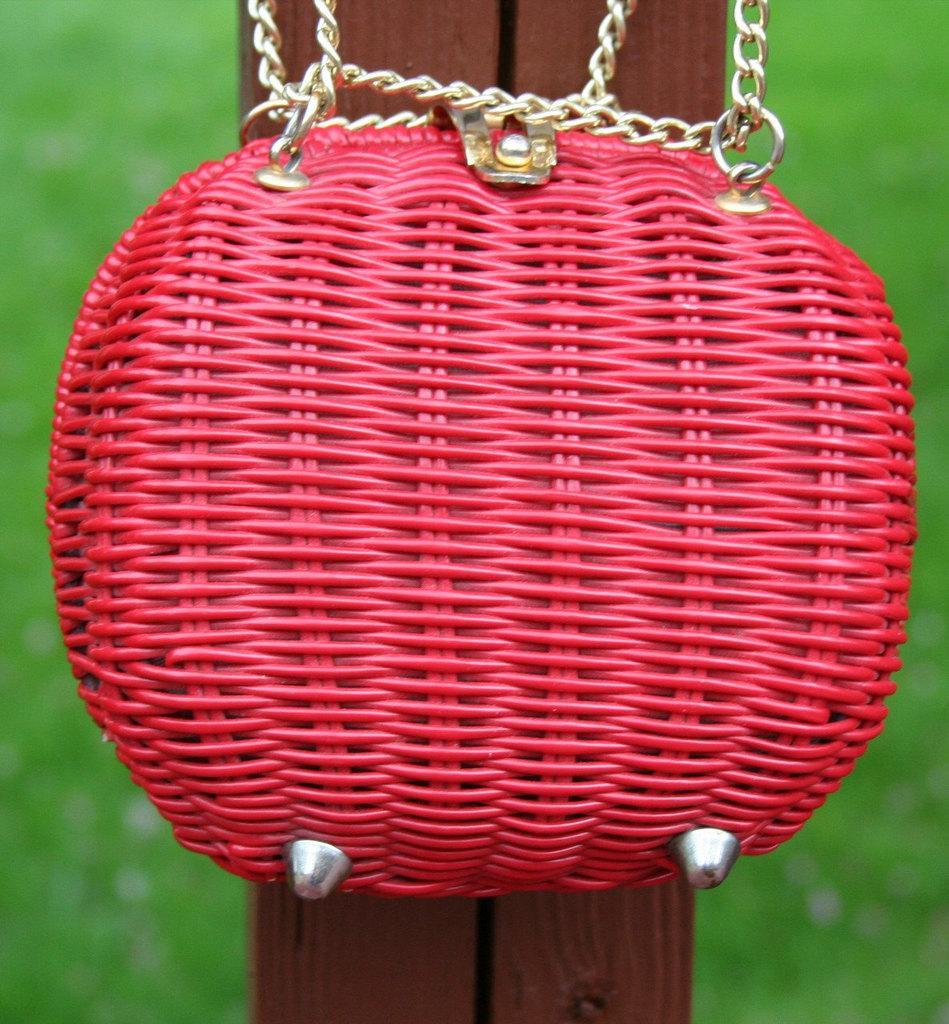Can you describe this image briefly? To the wooden stick there is a red color bag with chains connected to it. In the background there is a green grass. 